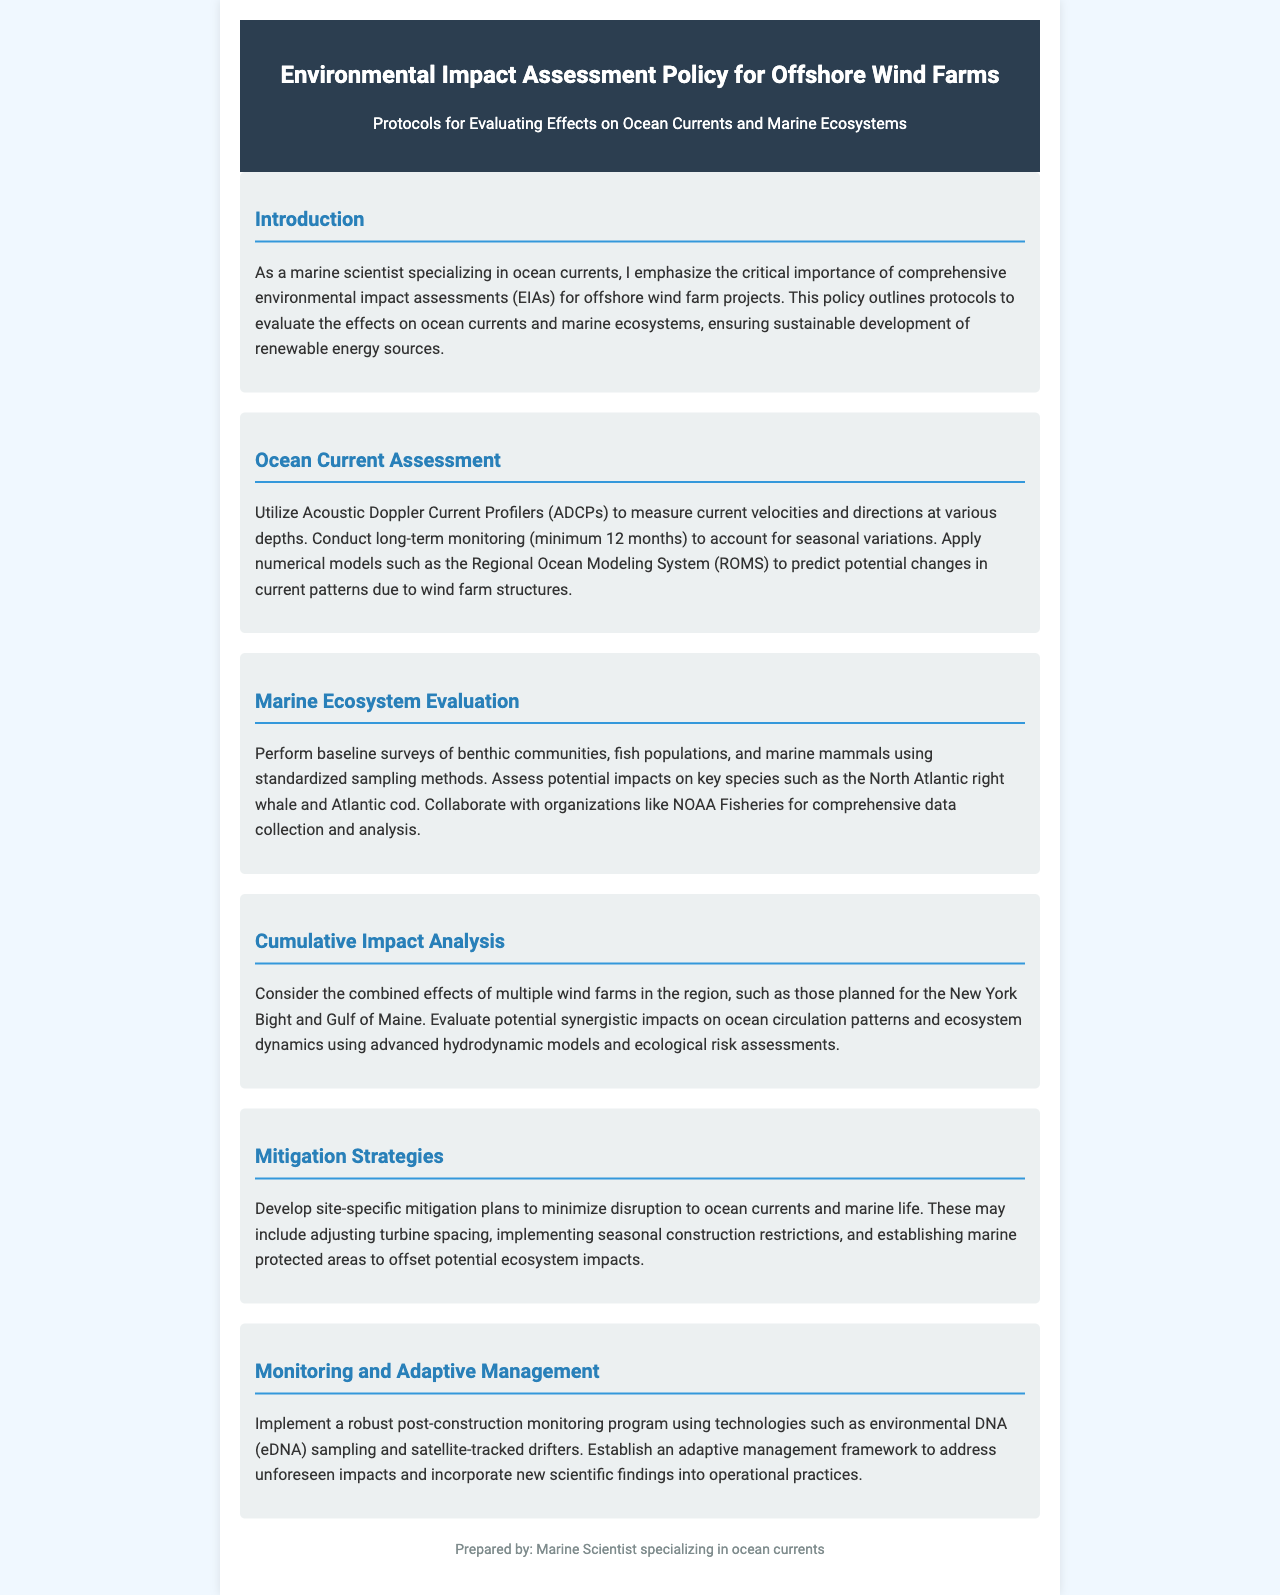What is the purpose of the policy? The purpose of the policy is to outline protocols to evaluate the effects on ocean currents and marine ecosystems, ensuring sustainable development of renewable energy sources.
Answer: to evaluate effects on ocean currents and marine ecosystems What measurement technology is recommended for current assessment? The recommended technology for measuring current velocities and directions is Acoustic Doppler Current Profilers.
Answer: Acoustic Doppler Current Profilers How long should the long-term monitoring last? The document states that long-term monitoring should last a minimum of 12 months.
Answer: 12 months Which whale species is mentioned as a key species? The North Atlantic right whale is mentioned as a key species to assess potential impacts.
Answer: North Atlantic right whale What is one of the mitigation strategies suggested? One suggested mitigation strategy is adjusting turbine spacing.
Answer: adjusting turbine spacing Which modeling approach is used for cumulative impact analysis? The advanced hydrodynamic models and ecological risk assessments are used.
Answer: advanced hydrodynamic models and ecological risk assessments What type of monitoring program should be implemented post-construction? The document recommends implementing a robust post-construction monitoring program.
Answer: robust post-construction monitoring program Which organization is recommended for collaboration in data collection? NOAA Fisheries is mentioned for collaboration in comprehensive data collection and analysis.
Answer: NOAA Fisheries 